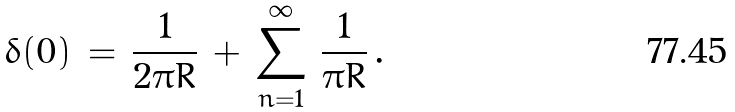Convert formula to latex. <formula><loc_0><loc_0><loc_500><loc_500>\delta ( 0 ) \, = \, \frac { 1 } { 2 \pi R } \, + \, \sum _ { n = 1 } ^ { \infty } \, \frac { 1 } { \pi R } \, .</formula> 